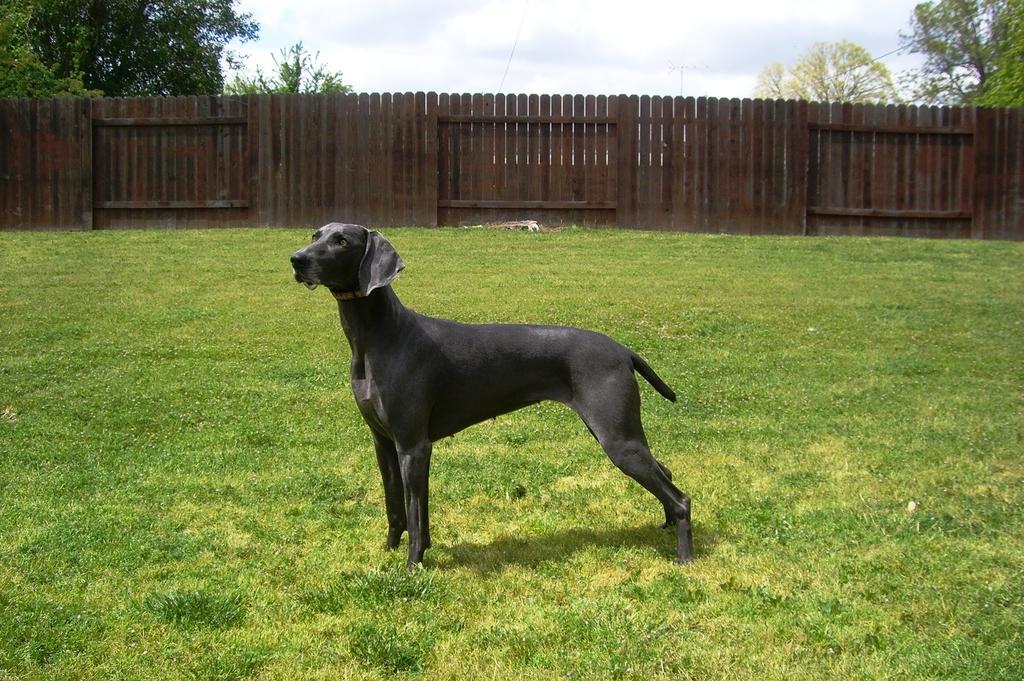In one or two sentences, can you explain what this image depicts? In this image we can see a dog. At the bottom of the image there is grass. In the background of the image there are trees, fencing, sky and clouds. 